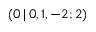<formula> <loc_0><loc_0><loc_500><loc_500>( 0 \, | \, 0 , 1 , - 2 ; 2 )</formula> 